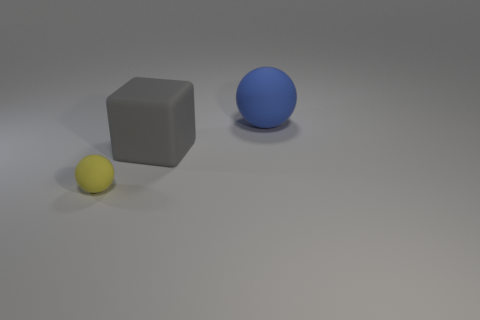The tiny yellow thing has what shape?
Your answer should be compact. Sphere. How many red things are big things or small balls?
Make the answer very short. 0. What number of other things are the same material as the large blue ball?
Provide a short and direct response. 2. There is a matte object that is behind the large gray thing; is its shape the same as the tiny yellow object?
Your answer should be very brief. Yes. Are there any blue balls?
Your response must be concise. Yes. Are there any other things that are the same shape as the big gray rubber thing?
Provide a short and direct response. No. Is the number of matte blocks behind the large blue ball greater than the number of small cyan metallic cylinders?
Make the answer very short. No. There is a big rubber block; are there any matte balls to the left of it?
Your answer should be very brief. Yes. Is the blue rubber object the same size as the yellow sphere?
Give a very brief answer. No. There is another thing that is the same shape as the yellow rubber object; what size is it?
Keep it short and to the point. Large. 